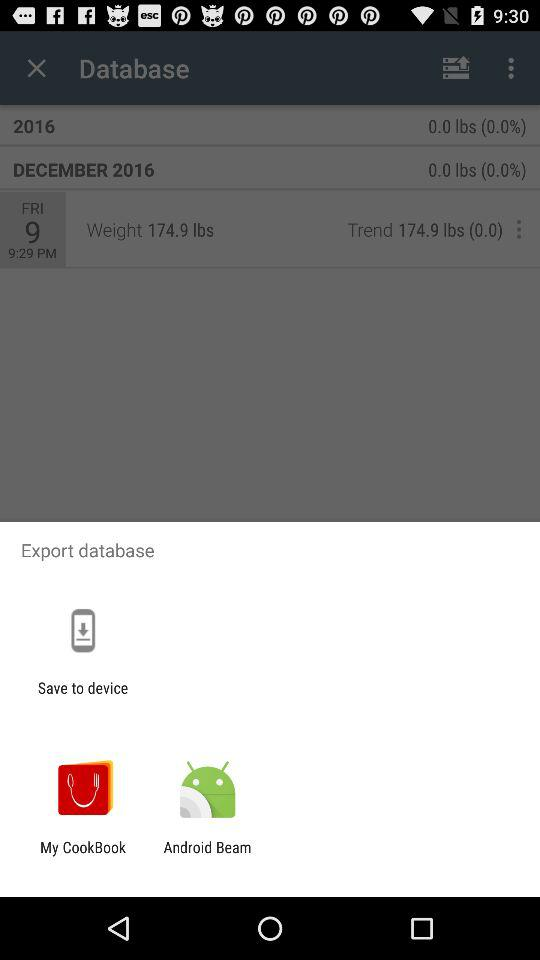What is the weight of the user?
Answer the question using a single word or phrase. 174.9 lbs 